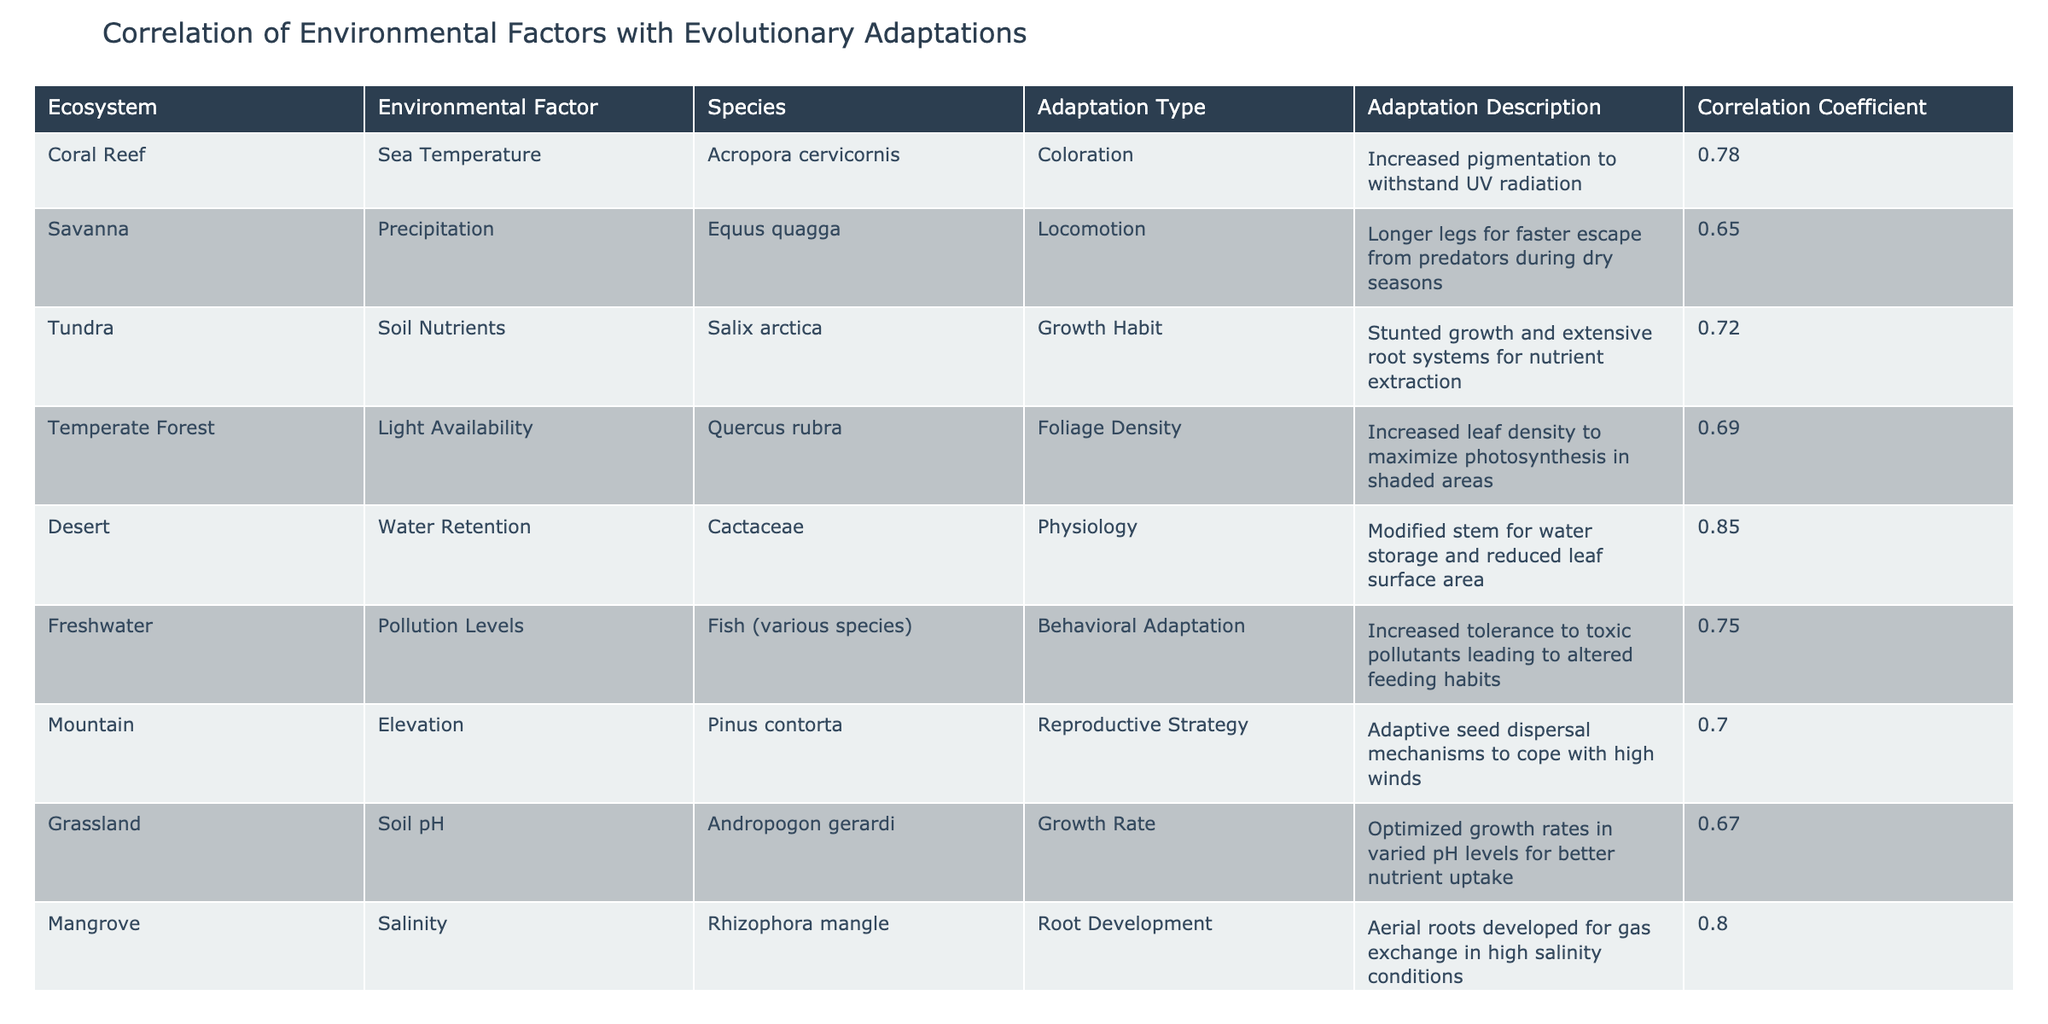What is the correlation coefficient for the adaptation type of Coloration in the Coral Reef ecosystem? The table indicates that for the Coral Reef ecosystem, the adaptation type of Coloration has a correlation coefficient of 0.78. This value is explicitly stated in the row corresponding to Coral Reef and Acropora cervicornis.
Answer: 0.78 Which species has the highest correlation with an environmental factor, and what is that correlation? By examining the table, I identify that the species Cactaceae in the Desert ecosystem has the highest correlation coefficient of 0.85 with the environmental factor of Water Retention.
Answer: Cactaceae; 0.85 What adaptations are observed for the species Equus quagga in relation to precipitation, and how does this reflect its correlation coefficient? The table shows that Equus quagga in the Savanna exhibits the adaptation type of Locomotion, characterized by longer legs for faster escape during dry seasons. The correlation coefficient is 0.65, indicating a moderate positive relationship with precipitation, suggesting this adaptation is beneficial under those conditions.
Answer: Longer legs for faster escape; 0.65 Is there a species with a correlation coefficient below 0.70? If yes, provide the species name and the correlation coefficient. Yes, the species Andropogon gerardi in the Grassland ecosystem has a correlation coefficient of 0.67, which is below 0.70, indicating less strength in the relationship between soil pH and growth rate adaptations.
Answer: Yes; Andropogon gerardi; 0.67 What is the average correlation coefficient for adaptations related to growth habits across different ecosystems? To find the average, I identify all entries related to growth habits: Salix arctica in Tundra (0.72), Taxodium distichum in Wetland (0.74), and Andropogon gerardi in Grassland (0.67). The sum of these coefficients is (0.72 + 0.74 + 0.67) = 2.13. Dividing by the number of species (3) gives an average of 2.13/3 = 0.71.
Answer: 0.71 